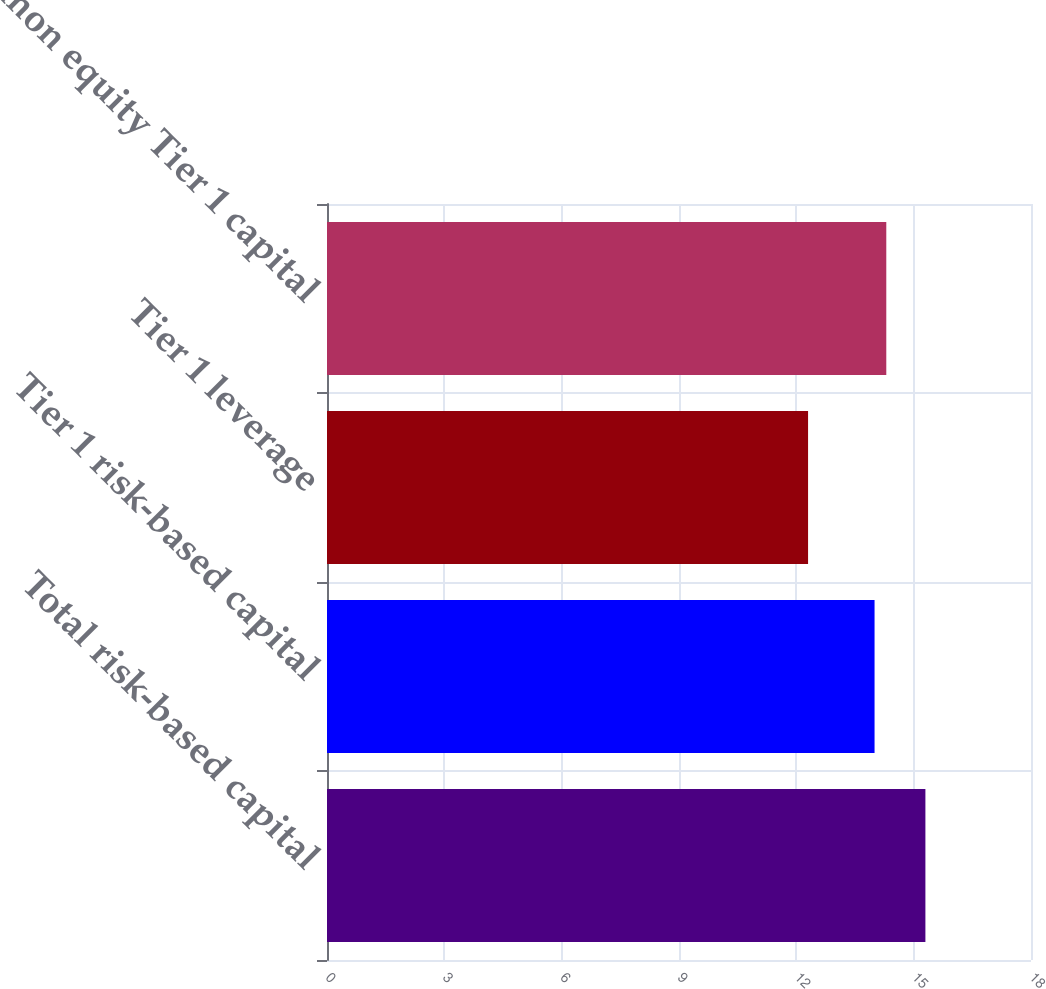Convert chart to OTSL. <chart><loc_0><loc_0><loc_500><loc_500><bar_chart><fcel>Total risk-based capital<fcel>Tier 1 risk-based capital<fcel>Tier 1 leverage<fcel>Common equity Tier 1 capital<nl><fcel>15.3<fcel>14<fcel>12.3<fcel>14.3<nl></chart> 